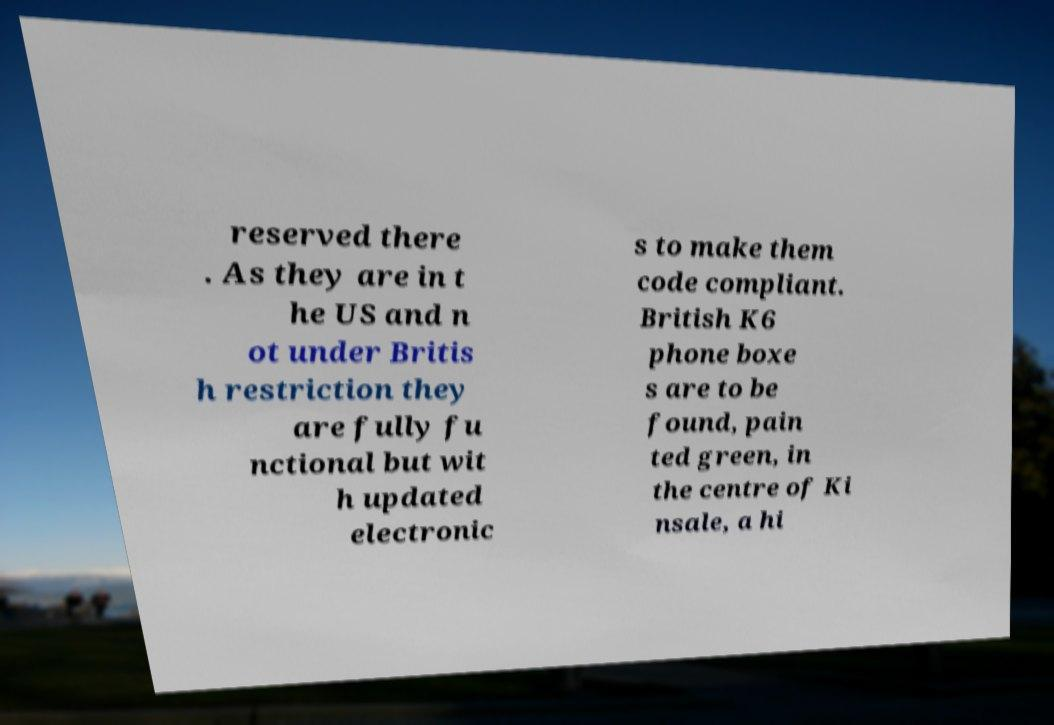Can you accurately transcribe the text from the provided image for me? reserved there . As they are in t he US and n ot under Britis h restriction they are fully fu nctional but wit h updated electronic s to make them code compliant. British K6 phone boxe s are to be found, pain ted green, in the centre of Ki nsale, a hi 